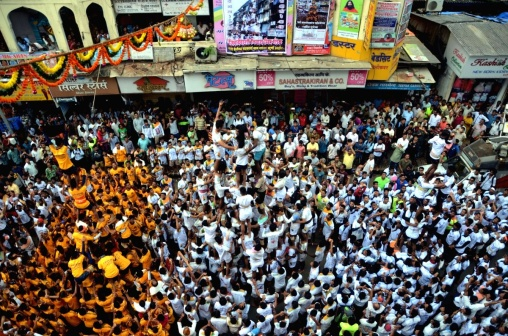How do the decorations contribute to the atmosphere of the event? The overhead decorations include strings of flowers and tassels that introduce bright colors above the crowd, enhancing the festive mood. They are a hallmark of celebration, often used in various cultures to signify joy and festivity, adding to the overall aesthetic and emotional impact of the event. 